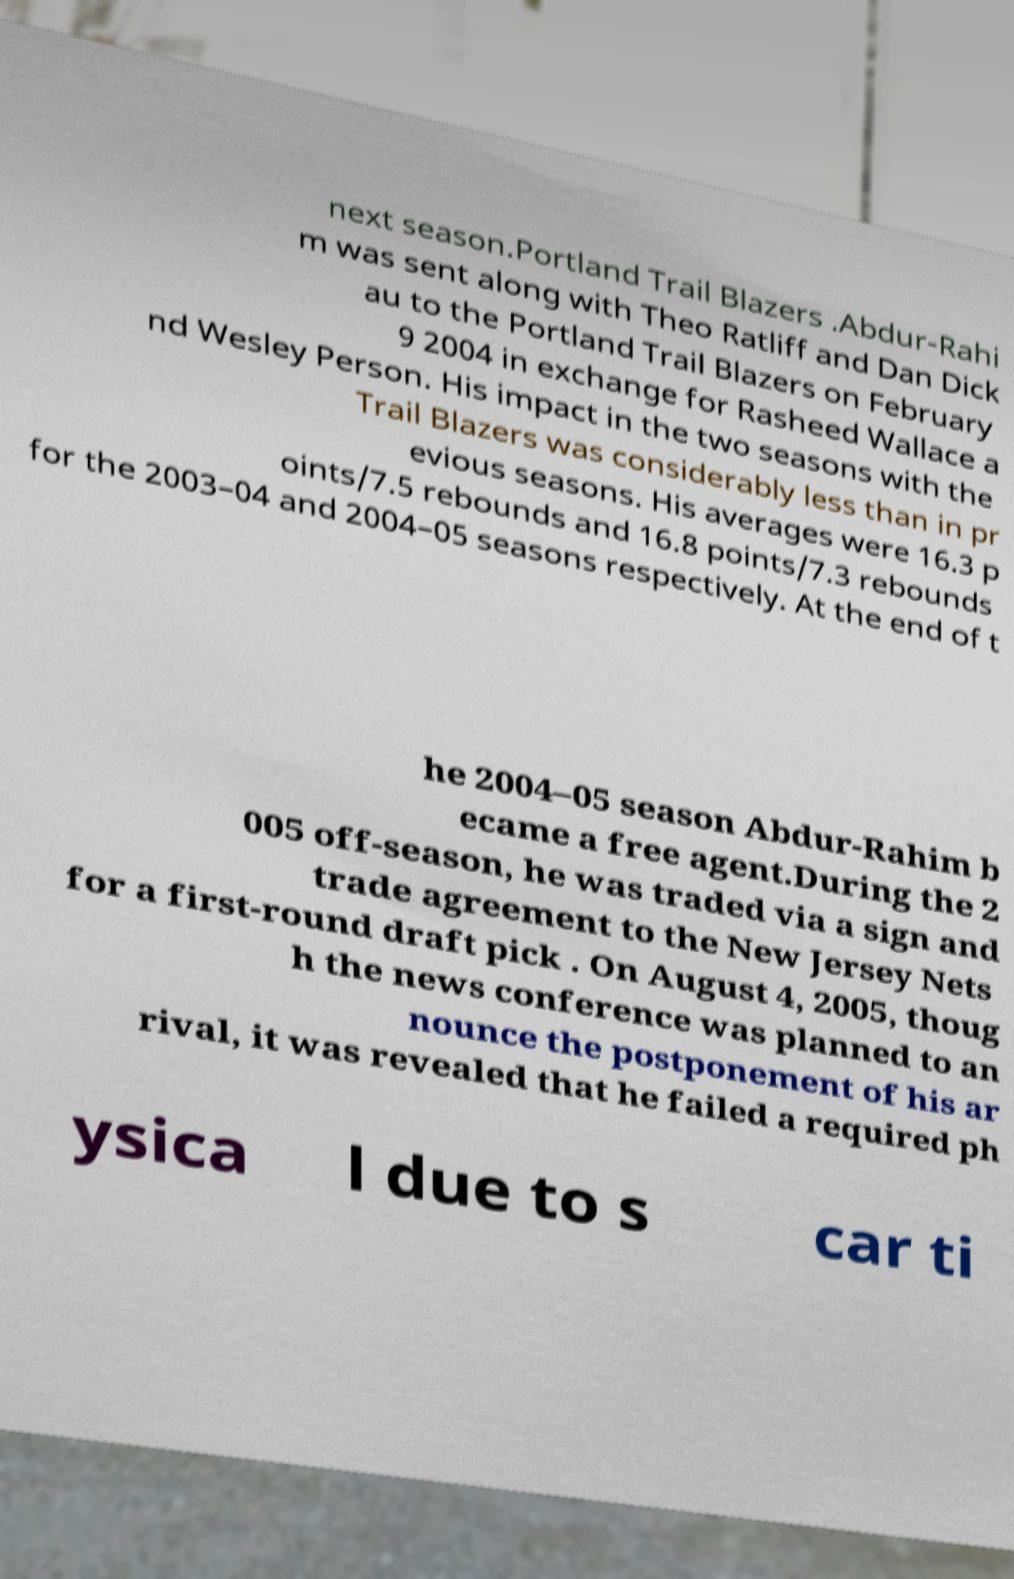Please read and relay the text visible in this image. What does it say? next season.Portland Trail Blazers .Abdur-Rahi m was sent along with Theo Ratliff and Dan Dick au to the Portland Trail Blazers on February 9 2004 in exchange for Rasheed Wallace a nd Wesley Person. His impact in the two seasons with the Trail Blazers was considerably less than in pr evious seasons. His averages were 16.3 p oints/7.5 rebounds and 16.8 points/7.3 rebounds for the 2003–04 and 2004–05 seasons respectively. At the end of t he 2004–05 season Abdur-Rahim b ecame a free agent.During the 2 005 off-season, he was traded via a sign and trade agreement to the New Jersey Nets for a first-round draft pick . On August 4, 2005, thoug h the news conference was planned to an nounce the postponement of his ar rival, it was revealed that he failed a required ph ysica l due to s car ti 